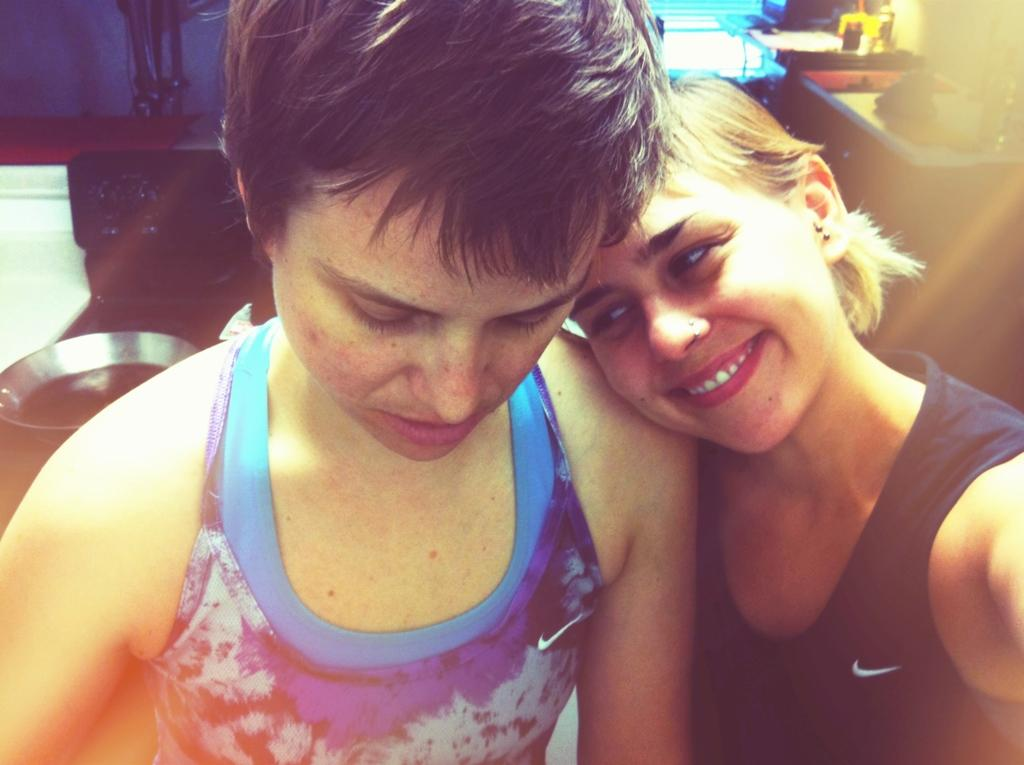How many people are present in the image? There are two persons in the image. What can be seen on the right side of the image? There is an object on the right side of the image. What can be seen on the left side of the image? There is an object on the left side of the image. What is behind the persons in the image? There is a wall behind the persons in the image. What type of shop can be seen in the image? There is no shop present in the image. What kind of hospital is visible in the image? There is no hospital present in the image. 